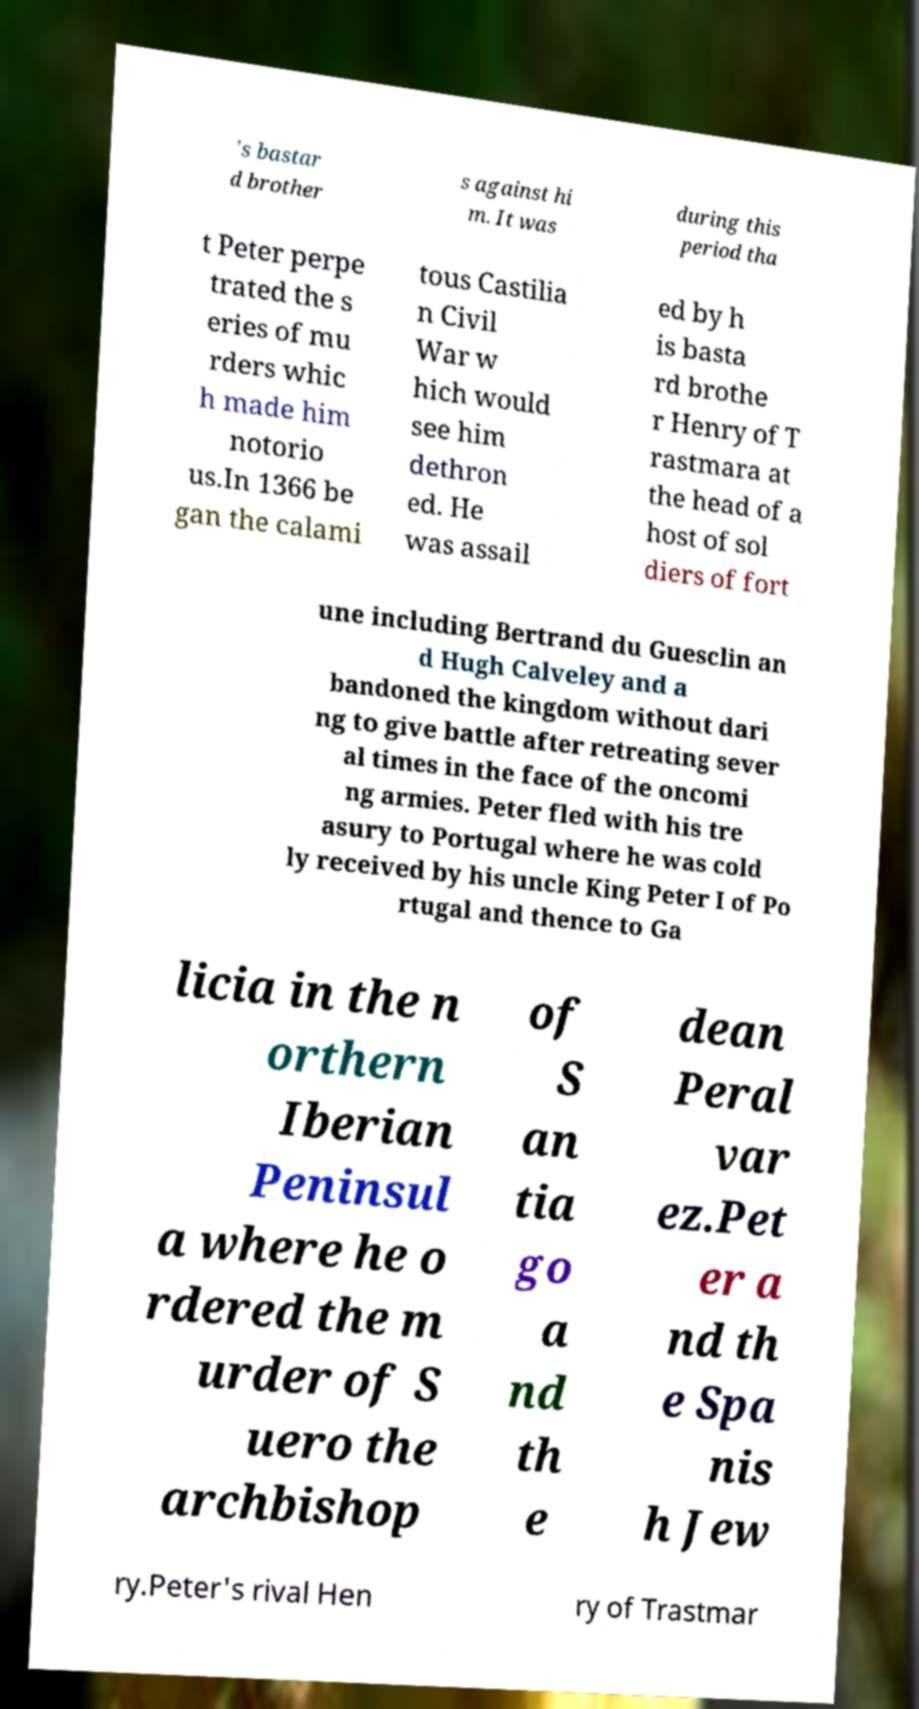Please read and relay the text visible in this image. What does it say? 's bastar d brother s against hi m. It was during this period tha t Peter perpe trated the s eries of mu rders whic h made him notorio us.In 1366 be gan the calami tous Castilia n Civil War w hich would see him dethron ed. He was assail ed by h is basta rd brothe r Henry of T rastmara at the head of a host of sol diers of fort une including Bertrand du Guesclin an d Hugh Calveley and a bandoned the kingdom without dari ng to give battle after retreating sever al times in the face of the oncomi ng armies. Peter fled with his tre asury to Portugal where he was cold ly received by his uncle King Peter I of Po rtugal and thence to Ga licia in the n orthern Iberian Peninsul a where he o rdered the m urder of S uero the archbishop of S an tia go a nd th e dean Peral var ez.Pet er a nd th e Spa nis h Jew ry.Peter's rival Hen ry of Trastmar 